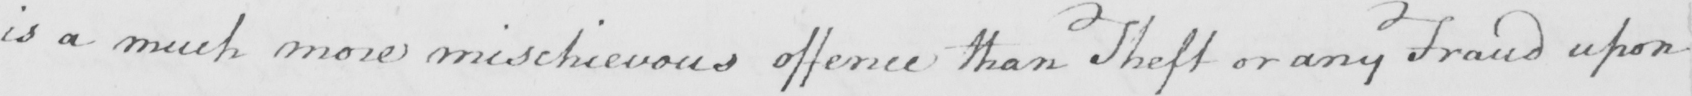Can you read and transcribe this handwriting? is a much more mischievous offence than Theft or any Fraud upon 